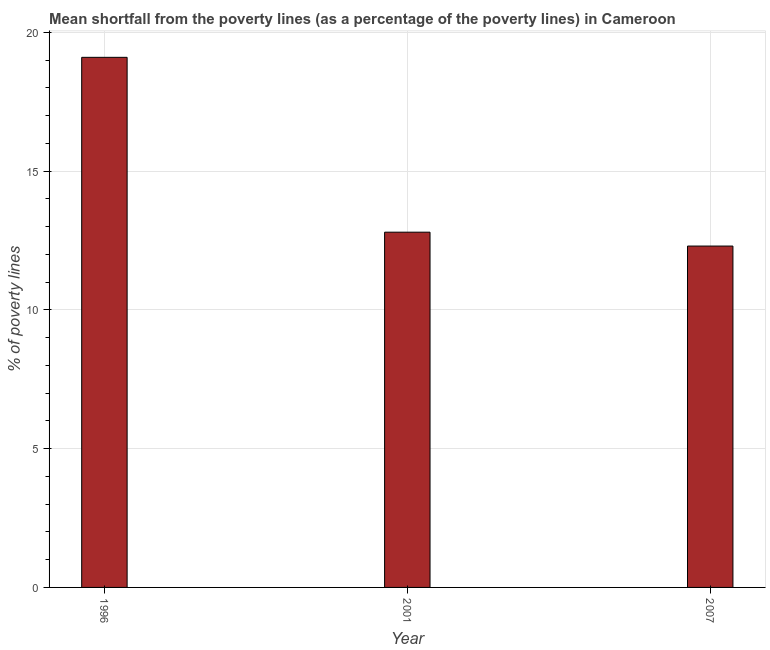Does the graph contain any zero values?
Offer a very short reply. No. What is the title of the graph?
Provide a succinct answer. Mean shortfall from the poverty lines (as a percentage of the poverty lines) in Cameroon. What is the label or title of the X-axis?
Keep it short and to the point. Year. What is the label or title of the Y-axis?
Provide a short and direct response. % of poverty lines. What is the poverty gap at national poverty lines in 1996?
Keep it short and to the point. 19.1. Across all years, what is the maximum poverty gap at national poverty lines?
Offer a terse response. 19.1. Across all years, what is the minimum poverty gap at national poverty lines?
Give a very brief answer. 12.3. In which year was the poverty gap at national poverty lines maximum?
Keep it short and to the point. 1996. What is the sum of the poverty gap at national poverty lines?
Offer a very short reply. 44.2. What is the average poverty gap at national poverty lines per year?
Give a very brief answer. 14.73. What is the ratio of the poverty gap at national poverty lines in 2001 to that in 2007?
Provide a succinct answer. 1.04. Is the poverty gap at national poverty lines in 1996 less than that in 2001?
Your answer should be very brief. No. What is the difference between the highest and the lowest poverty gap at national poverty lines?
Make the answer very short. 6.8. How many bars are there?
Provide a short and direct response. 3. How many years are there in the graph?
Ensure brevity in your answer.  3. Are the values on the major ticks of Y-axis written in scientific E-notation?
Offer a terse response. No. What is the % of poverty lines in 2001?
Make the answer very short. 12.8. What is the difference between the % of poverty lines in 1996 and 2001?
Your answer should be very brief. 6.3. What is the difference between the % of poverty lines in 1996 and 2007?
Offer a very short reply. 6.8. What is the difference between the % of poverty lines in 2001 and 2007?
Offer a very short reply. 0.5. What is the ratio of the % of poverty lines in 1996 to that in 2001?
Your response must be concise. 1.49. What is the ratio of the % of poverty lines in 1996 to that in 2007?
Your answer should be compact. 1.55. What is the ratio of the % of poverty lines in 2001 to that in 2007?
Ensure brevity in your answer.  1.04. 